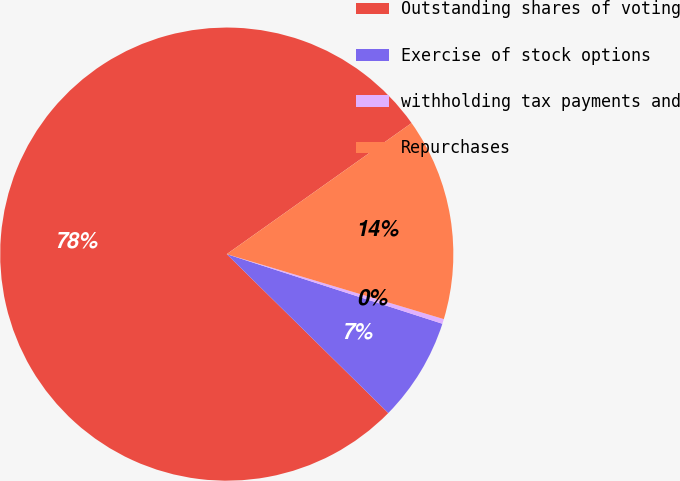Convert chart to OTSL. <chart><loc_0><loc_0><loc_500><loc_500><pie_chart><fcel>Outstanding shares of voting<fcel>Exercise of stock options<fcel>withholding tax payments and<fcel>Repurchases<nl><fcel>77.81%<fcel>7.4%<fcel>0.34%<fcel>14.45%<nl></chart> 